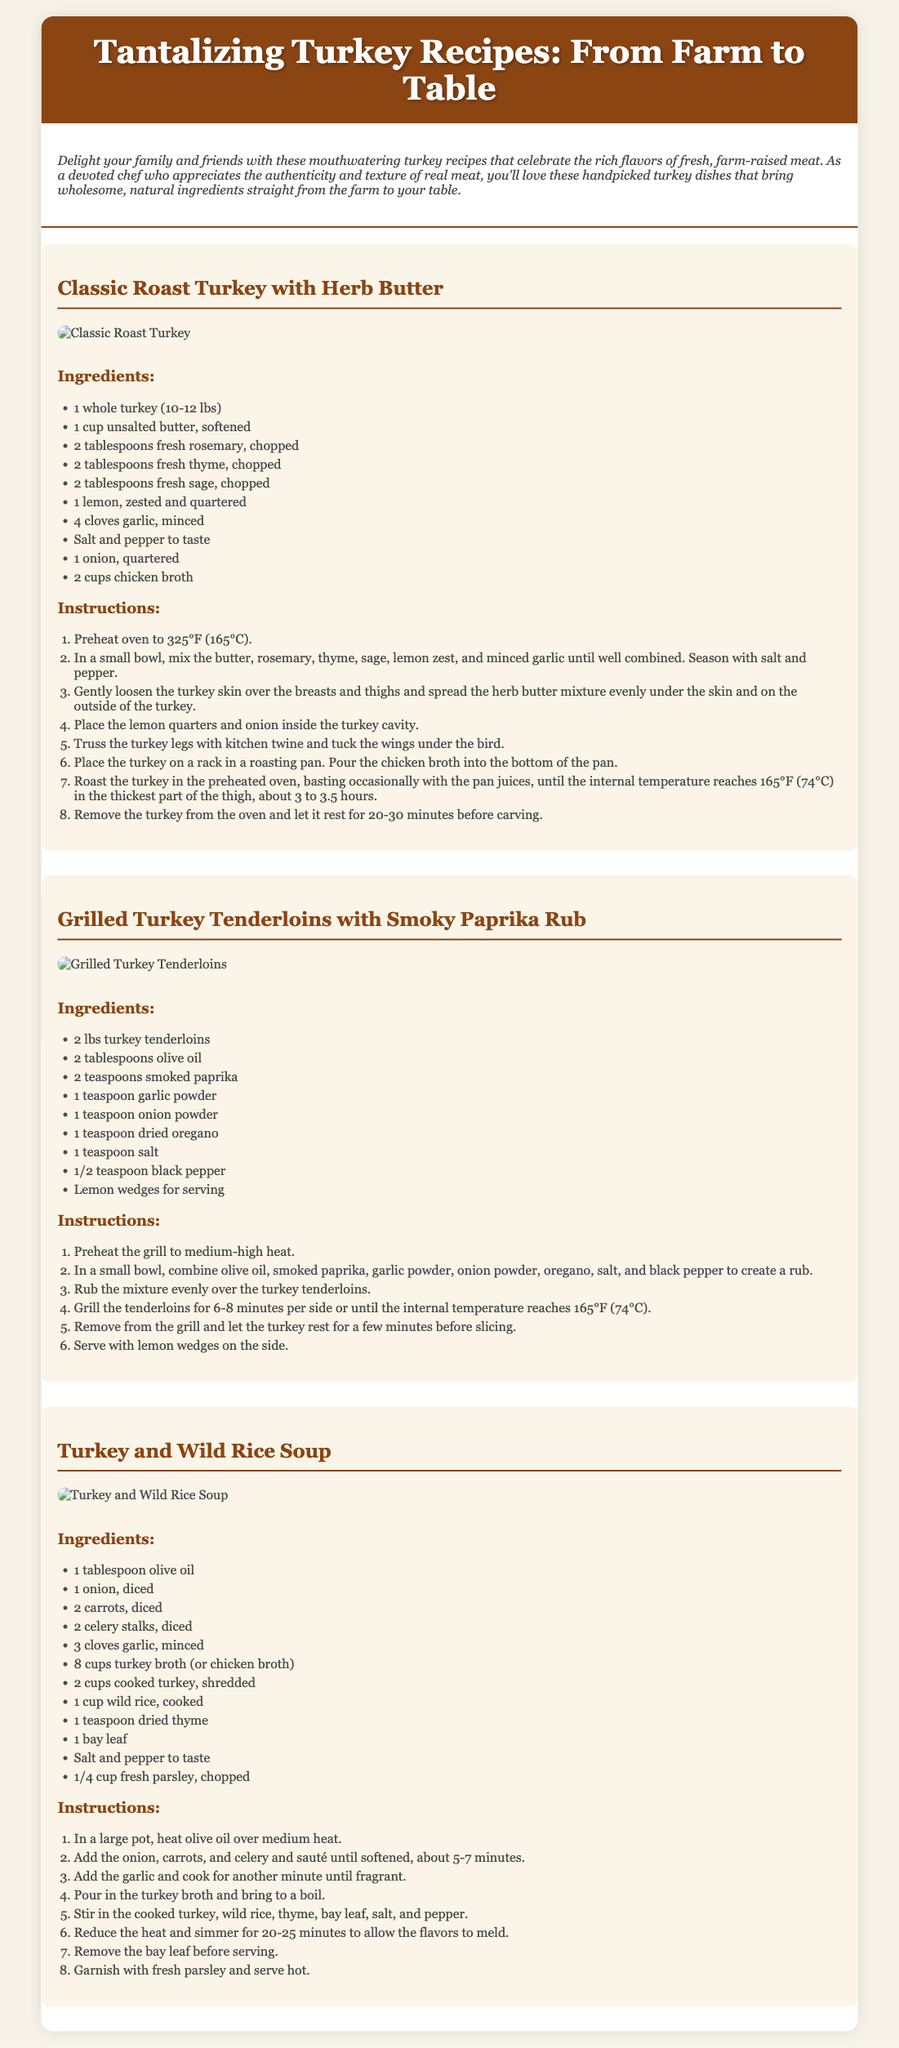what is the title of the recipe card? The title of the recipe card is prominently displayed at the top of the document.
Answer: Tantalizing Turkey Recipes: From Farm to Table how many recipes are included in the document? The document lists three distinct turkey recipes, each in its own section.
Answer: 3 what is the main ingredient in the Classic Roast Turkey recipe? The main ingredient is listed at the beginning of the ingredients section for this recipe.
Answer: whole turkey what temperature should the oven be preheated to for the Classic Roast Turkey? This information can be found in the instructions for the Classic Roast Turkey recipe.
Answer: 325°F how long should the turkey tenderloins be grilled per side? This duration is specified in the instructions for grilling the turkey tenderloins.
Answer: 6-8 minutes which herb is used in the herb butter for the Classic Roast Turkey? The recipe specifically mentions several herbs, and rosemary is one of them.
Answer: rosemary what is the cooking method for the Turkey and Wild Rice Soup? The method described involves heating ingredients in a pot, which indicates a specific cooking technique.
Answer: simmering what garnishment is suggested for the Turkey and Wild Rice Soup? This detail is included in the final steps of the soup recipe instructions.
Answer: fresh parsley 